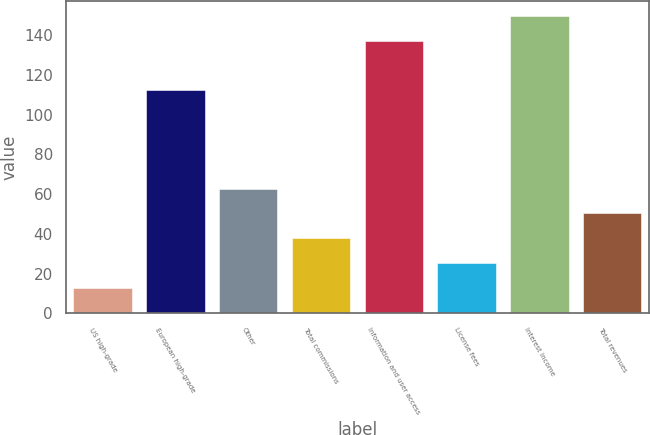Convert chart. <chart><loc_0><loc_0><loc_500><loc_500><bar_chart><fcel>US high-grade<fcel>European high-grade<fcel>Other<fcel>Total commissions<fcel>Information and user access<fcel>License fees<fcel>Interest income<fcel>Total revenues<nl><fcel>12.8<fcel>112.5<fcel>62.76<fcel>37.78<fcel>137.2<fcel>25.29<fcel>149.69<fcel>50.27<nl></chart> 